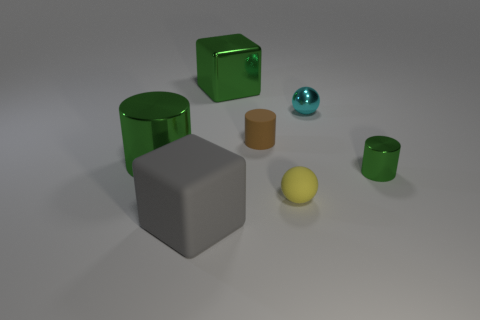What is the color of the small matte cylinder behind the big rubber object?
Offer a very short reply. Brown. There is a big thing that is behind the large matte thing and in front of the brown matte object; what is its material?
Provide a short and direct response. Metal. There is a large green metallic object that is to the right of the big gray thing; how many tiny yellow matte objects are to the right of it?
Your answer should be very brief. 1. The brown thing has what shape?
Your answer should be very brief. Cylinder. The other small thing that is made of the same material as the tiny cyan object is what shape?
Your response must be concise. Cylinder. Do the large object in front of the small metal cylinder and the tiny cyan thing have the same shape?
Your answer should be very brief. No. There is a green thing that is right of the tiny brown matte cylinder; what is its shape?
Make the answer very short. Cylinder. What is the shape of the big object that is the same color as the big shiny cylinder?
Ensure brevity in your answer.  Cube. What number of balls have the same size as the brown object?
Your answer should be compact. 2. The large cylinder has what color?
Your answer should be compact. Green. 